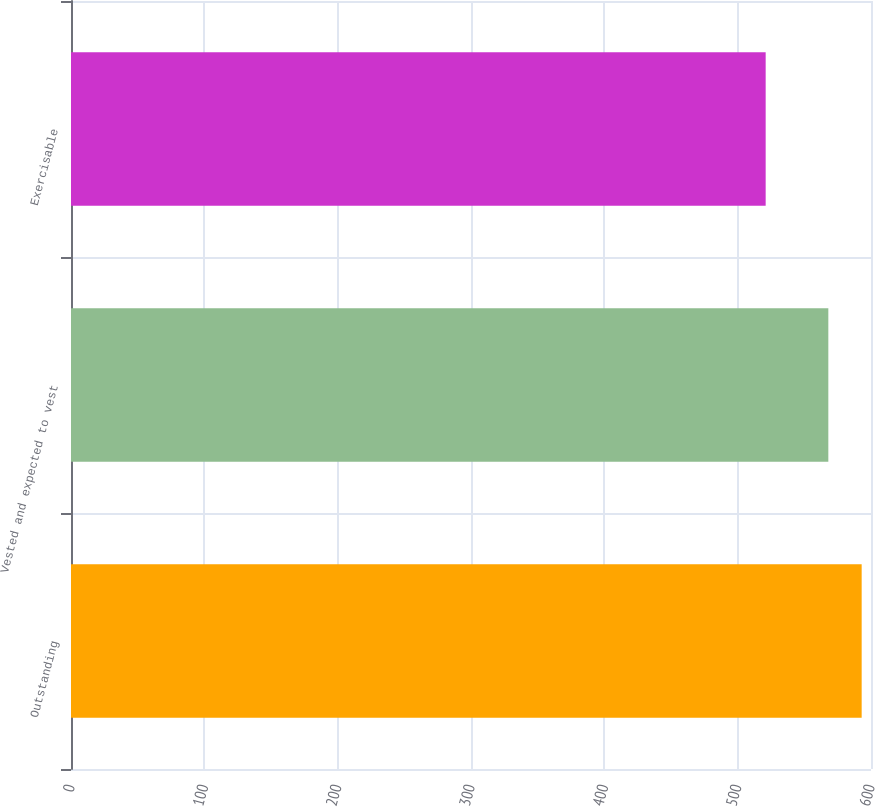<chart> <loc_0><loc_0><loc_500><loc_500><bar_chart><fcel>Outstanding<fcel>Vested and expected to vest<fcel>Exercisable<nl><fcel>593<fcel>568<fcel>521<nl></chart> 